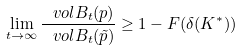<formula> <loc_0><loc_0><loc_500><loc_500>\lim _ { t \to \infty } \frac { \ v o l B _ { t } ( p ) } { \ v o l B _ { t } ( \tilde { p } ) } \geq 1 - F ( \delta ( K ^ { * } ) )</formula> 